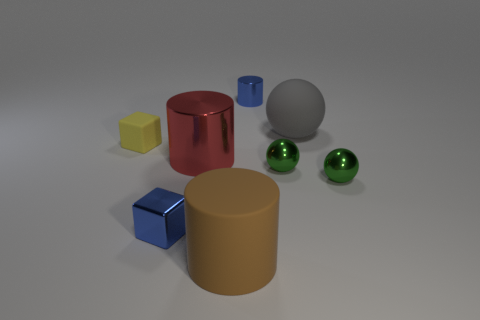Add 1 blue metal blocks. How many objects exist? 9 Subtract all cylinders. How many objects are left? 5 Add 4 big rubber cylinders. How many big rubber cylinders exist? 5 Subtract 0 brown cubes. How many objects are left? 8 Subtract all tiny blue objects. Subtract all small matte blocks. How many objects are left? 5 Add 4 green balls. How many green balls are left? 6 